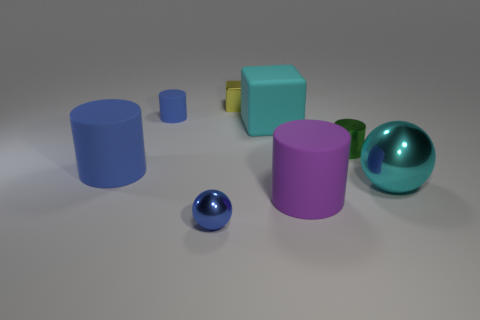Subtract all purple blocks. Subtract all gray spheres. How many blocks are left? 2 Add 2 metallic spheres. How many objects exist? 10 Subtract all cubes. How many objects are left? 6 Subtract all tiny blue balls. Subtract all small shiny cylinders. How many objects are left? 6 Add 7 tiny blue balls. How many tiny blue balls are left? 8 Add 5 tiny shiny cylinders. How many tiny shiny cylinders exist? 6 Subtract 0 blue blocks. How many objects are left? 8 